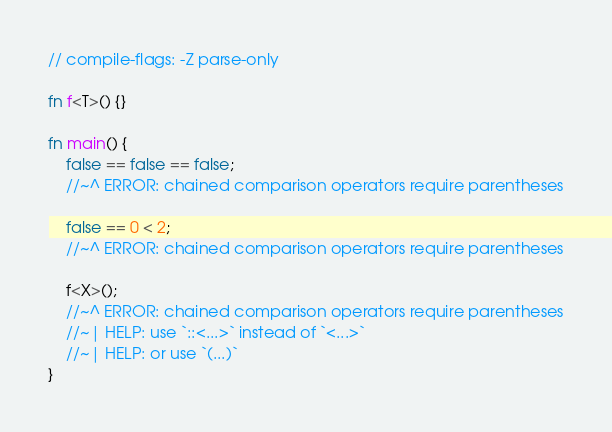<code> <loc_0><loc_0><loc_500><loc_500><_Rust_>// compile-flags: -Z parse-only

fn f<T>() {}

fn main() {
    false == false == false;
    //~^ ERROR: chained comparison operators require parentheses

    false == 0 < 2;
    //~^ ERROR: chained comparison operators require parentheses

    f<X>();
    //~^ ERROR: chained comparison operators require parentheses
    //~| HELP: use `::<...>` instead of `<...>`
    //~| HELP: or use `(...)`
}
</code> 